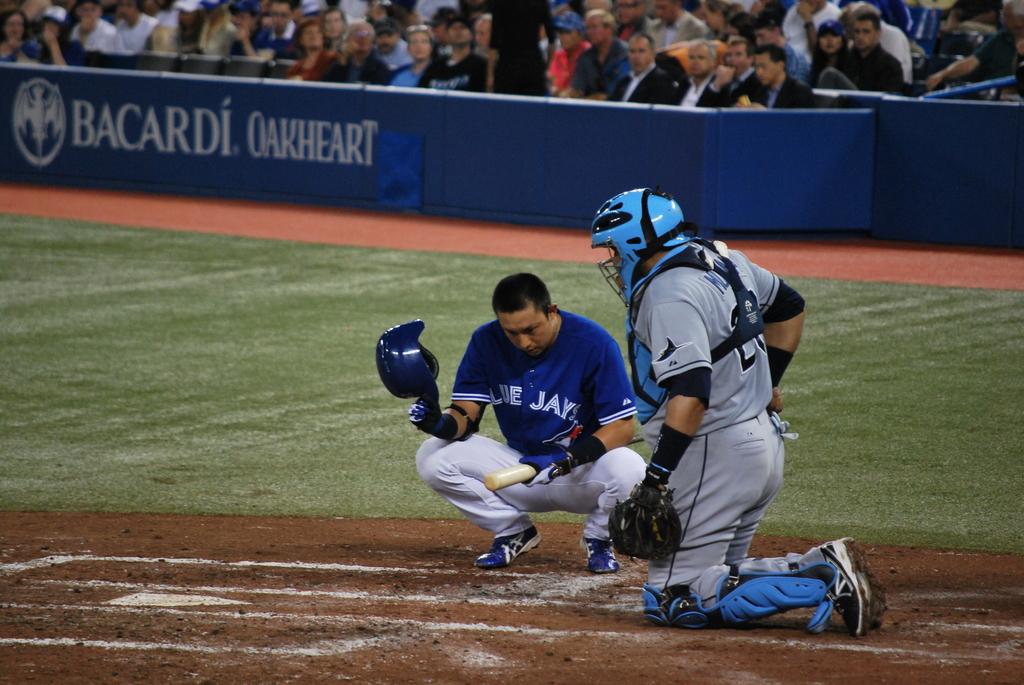What team does the batter play for?
Give a very brief answer. Blue jays. 